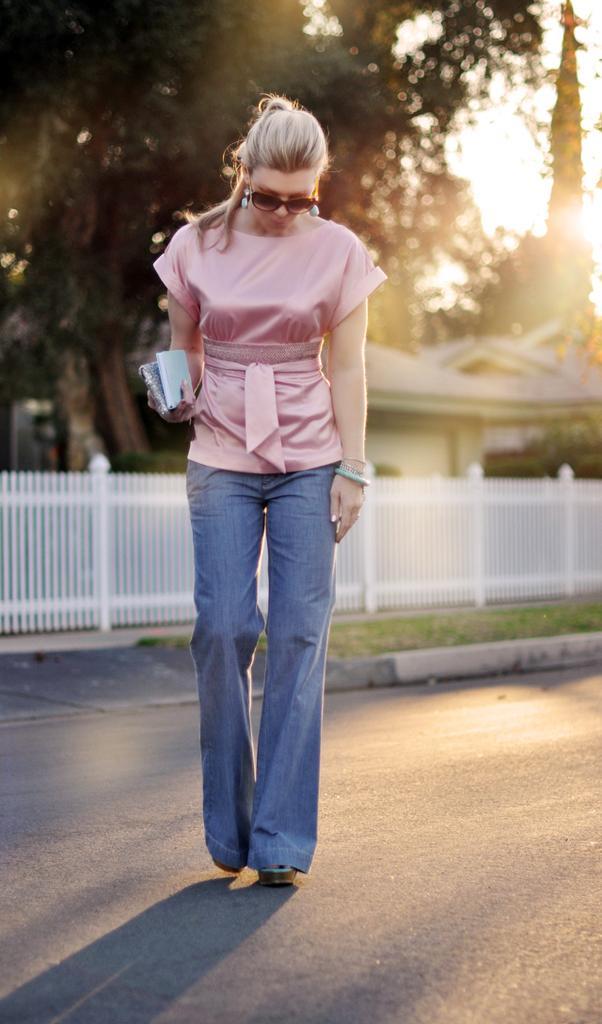Can you describe this image briefly? In this image there is women wearing pink color top, blue color jeans and walking on the road, in the background there is a fencing tree and houses. 